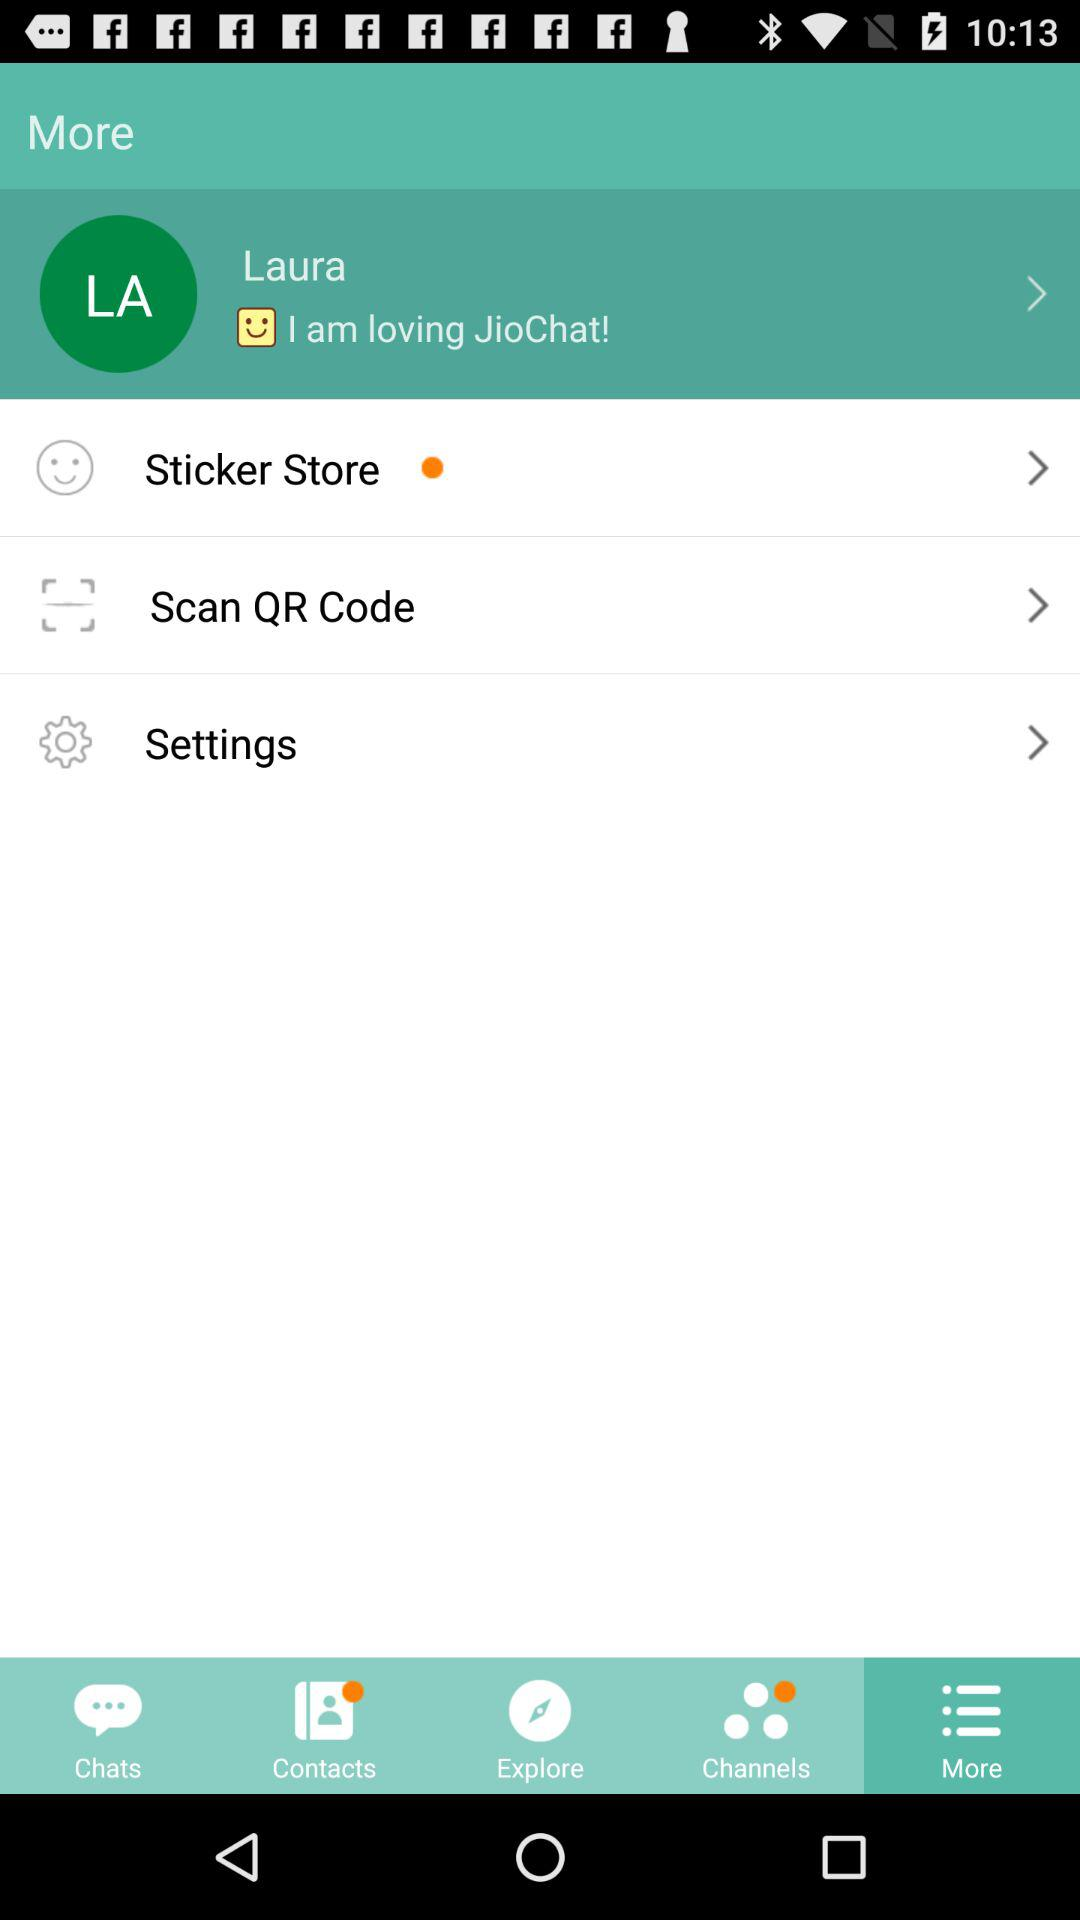What is the user name? The user name is Laura. 